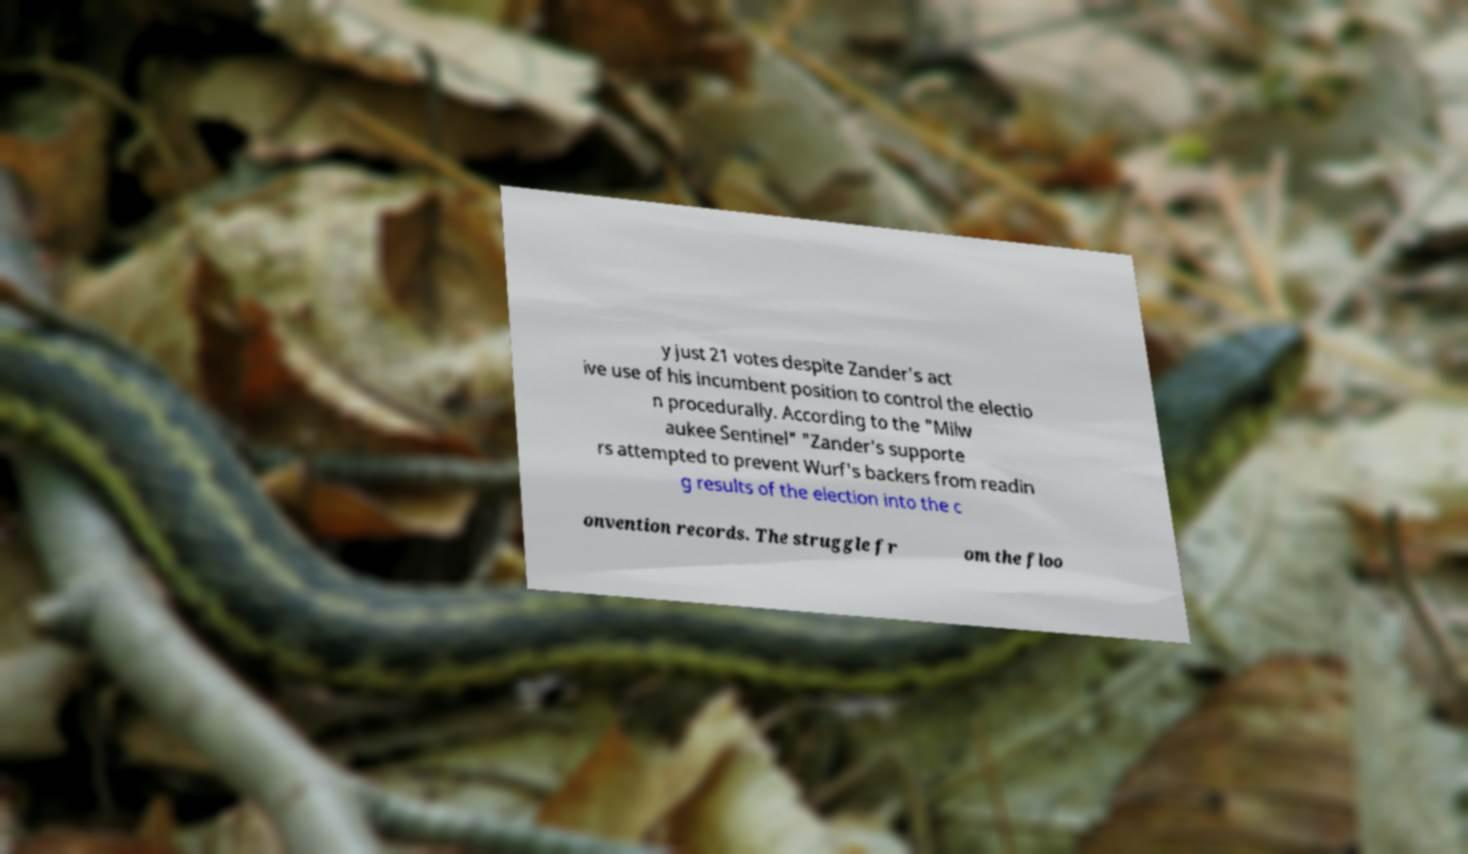Please identify and transcribe the text found in this image. The image shows a piece of paper with printed text that is partially obscured at the edges. From what is visible, it reads, '[...]y just 21 votes despite Zander's act[ive use] of his incumbent position to control the electio[n procedurally.] According to the "Milw[aukee Sentinel," Zander's supporte]rs attempted to prevent Wurf's backers from readin[g] results of the election into the c[onvention records. The struggle fr]om the floo[r...]'. Due to the blurred and obscured portions of the paper, some parts of the text are not legible. 